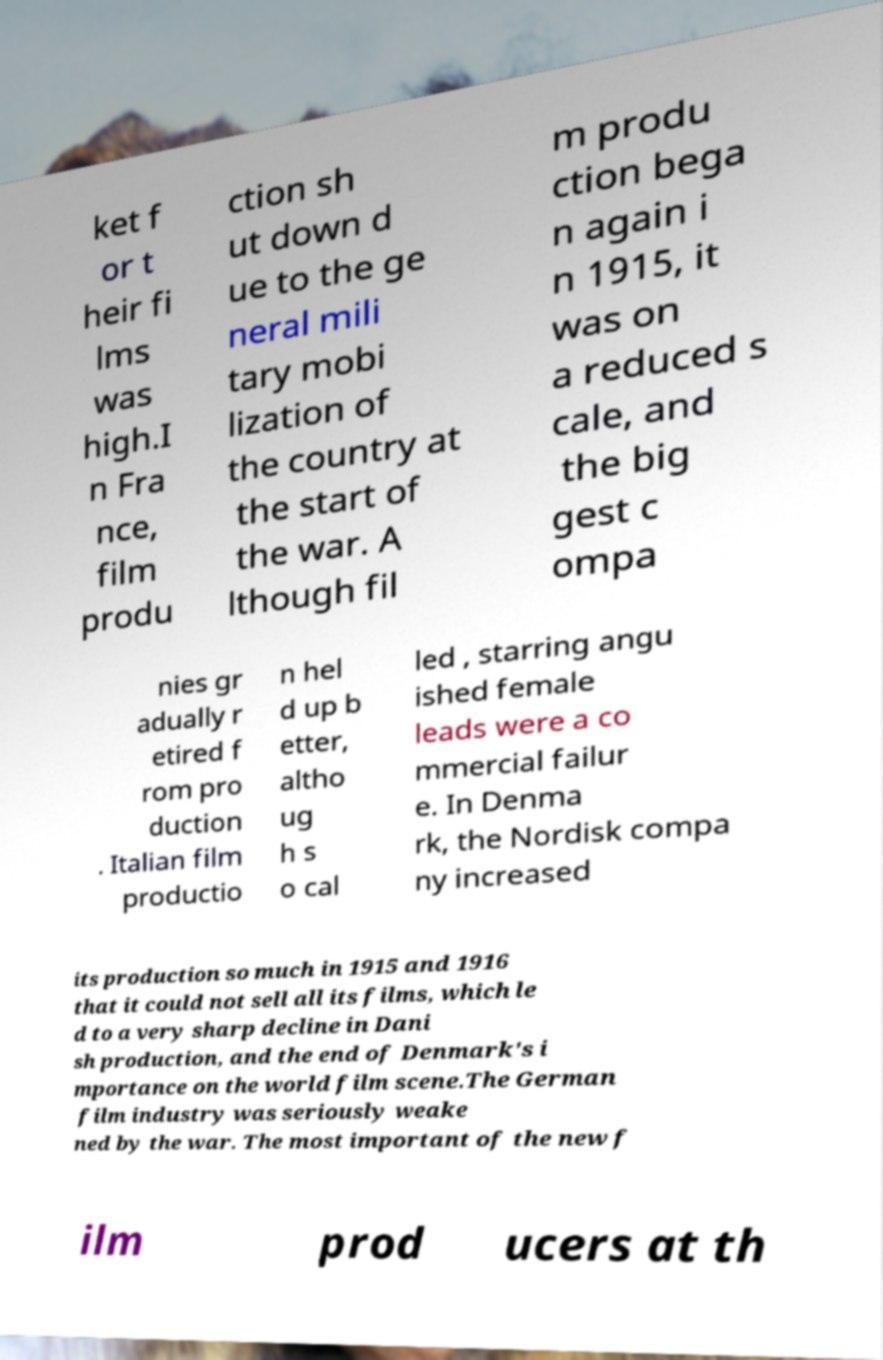Can you read and provide the text displayed in the image?This photo seems to have some interesting text. Can you extract and type it out for me? ket f or t heir fi lms was high.I n Fra nce, film produ ction sh ut down d ue to the ge neral mili tary mobi lization of the country at the start of the war. A lthough fil m produ ction bega n again i n 1915, it was on a reduced s cale, and the big gest c ompa nies gr adually r etired f rom pro duction . Italian film productio n hel d up b etter, altho ug h s o cal led , starring angu ished female leads were a co mmercial failur e. In Denma rk, the Nordisk compa ny increased its production so much in 1915 and 1916 that it could not sell all its films, which le d to a very sharp decline in Dani sh production, and the end of Denmark's i mportance on the world film scene.The German film industry was seriously weake ned by the war. The most important of the new f ilm prod ucers at th 